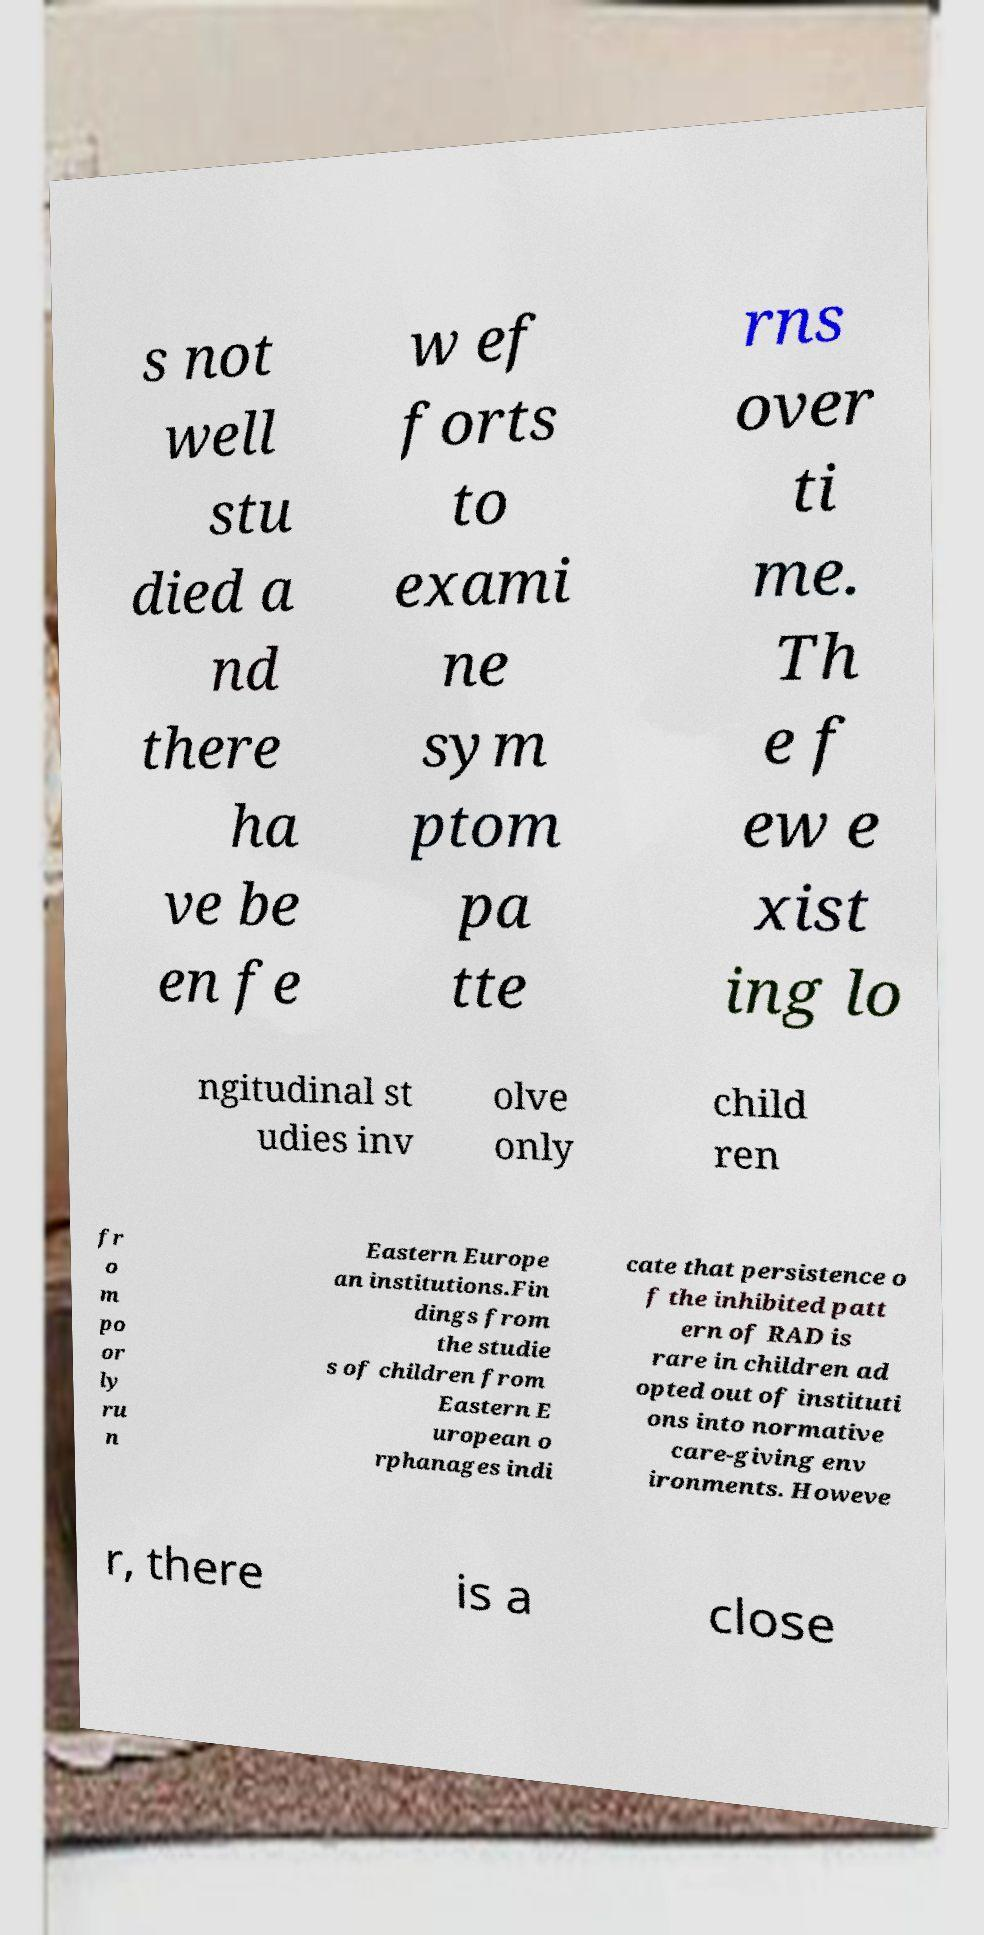Could you extract and type out the text from this image? s not well stu died a nd there ha ve be en fe w ef forts to exami ne sym ptom pa tte rns over ti me. Th e f ew e xist ing lo ngitudinal st udies inv olve only child ren fr o m po or ly ru n Eastern Europe an institutions.Fin dings from the studie s of children from Eastern E uropean o rphanages indi cate that persistence o f the inhibited patt ern of RAD is rare in children ad opted out of instituti ons into normative care-giving env ironments. Howeve r, there is a close 